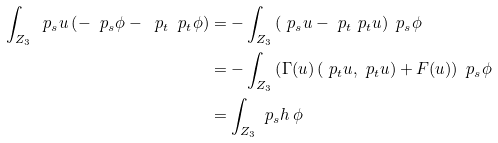<formula> <loc_0><loc_0><loc_500><loc_500>\int _ { Z _ { 3 } } \ p _ { s } u \left ( - \ p _ { s } \phi - \ p _ { t } \ p _ { t } \phi \right ) & = - \int _ { Z _ { 3 } } \left ( \ p _ { s } u - \ p _ { t } \ p _ { t } u \right ) \ p _ { s } \phi \\ & = - \int _ { Z _ { 3 } } \left ( \Gamma ( u ) \left ( \ p _ { t } u , \ p _ { t } u \right ) + F ( u ) \right ) \ p _ { s } \phi \\ & = \int _ { Z _ { 3 } } \ p _ { s } h \, \phi</formula> 